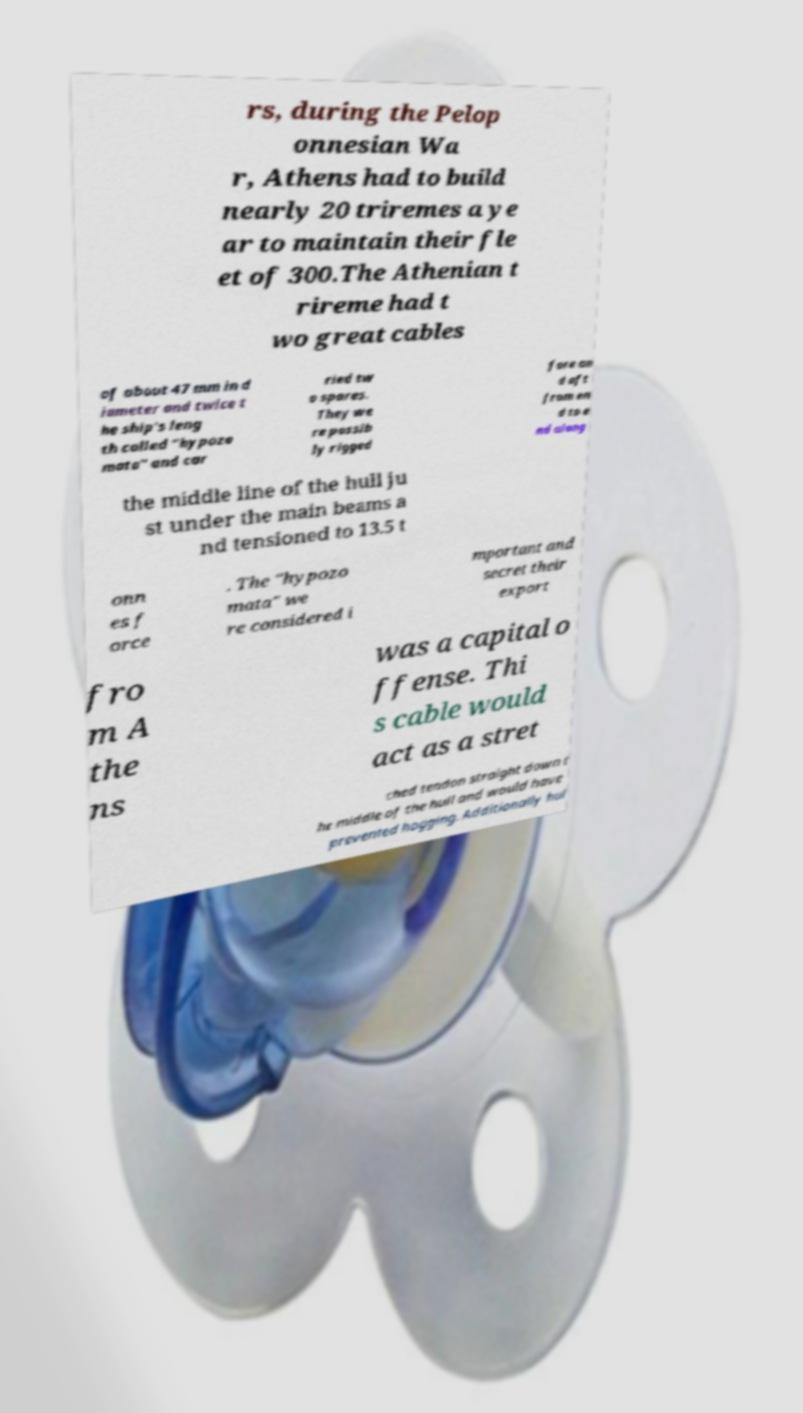Could you assist in decoding the text presented in this image and type it out clearly? rs, during the Pelop onnesian Wa r, Athens had to build nearly 20 triremes a ye ar to maintain their fle et of 300.The Athenian t rireme had t wo great cables of about 47 mm in d iameter and twice t he ship's leng th called "hypozo mata" and car ried tw o spares. They we re possib ly rigged fore an d aft from en d to e nd along the middle line of the hull ju st under the main beams a nd tensioned to 13.5 t onn es f orce . The "hypozo mata" we re considered i mportant and secret their export fro m A the ns was a capital o ffense. Thi s cable would act as a stret ched tendon straight down t he middle of the hull and would have prevented hogging. Additionally hul 